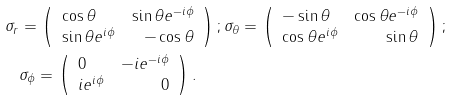Convert formula to latex. <formula><loc_0><loc_0><loc_500><loc_500>\sigma _ { r } & = \left ( \begin{array} { l r } \cos \theta & \sin \theta e ^ { - i \phi } \\ \sin \theta e ^ { i \phi } & - \cos \theta \end{array} \right ) ; \sigma _ { \theta } = \left ( \begin{array} { l r } - \sin \theta & \cos \theta e ^ { - i \phi } \\ \cos \theta e ^ { i \phi } & \sin \theta \end{array} \right ) ; \\ & \sigma _ { \phi } = \left ( \begin{array} { l r } 0 & - i e ^ { - i \phi } \\ i e ^ { i \phi } & 0 \end{array} \right ) .</formula> 